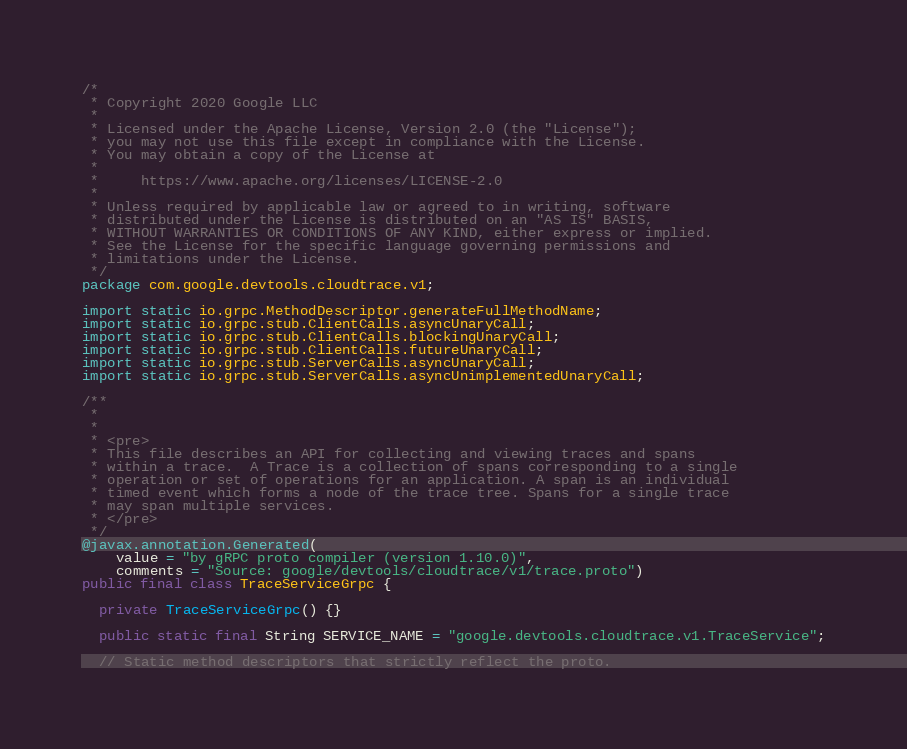Convert code to text. <code><loc_0><loc_0><loc_500><loc_500><_Java_>/*
 * Copyright 2020 Google LLC
 *
 * Licensed under the Apache License, Version 2.0 (the "License");
 * you may not use this file except in compliance with the License.
 * You may obtain a copy of the License at
 *
 *     https://www.apache.org/licenses/LICENSE-2.0
 *
 * Unless required by applicable law or agreed to in writing, software
 * distributed under the License is distributed on an "AS IS" BASIS,
 * WITHOUT WARRANTIES OR CONDITIONS OF ANY KIND, either express or implied.
 * See the License for the specific language governing permissions and
 * limitations under the License.
 */
package com.google.devtools.cloudtrace.v1;

import static io.grpc.MethodDescriptor.generateFullMethodName;
import static io.grpc.stub.ClientCalls.asyncUnaryCall;
import static io.grpc.stub.ClientCalls.blockingUnaryCall;
import static io.grpc.stub.ClientCalls.futureUnaryCall;
import static io.grpc.stub.ServerCalls.asyncUnaryCall;
import static io.grpc.stub.ServerCalls.asyncUnimplementedUnaryCall;

/**
 *
 *
 * <pre>
 * This file describes an API for collecting and viewing traces and spans
 * within a trace.  A Trace is a collection of spans corresponding to a single
 * operation or set of operations for an application. A span is an individual
 * timed event which forms a node of the trace tree. Spans for a single trace
 * may span multiple services.
 * </pre>
 */
@javax.annotation.Generated(
    value = "by gRPC proto compiler (version 1.10.0)",
    comments = "Source: google/devtools/cloudtrace/v1/trace.proto")
public final class TraceServiceGrpc {

  private TraceServiceGrpc() {}

  public static final String SERVICE_NAME = "google.devtools.cloudtrace.v1.TraceService";

  // Static method descriptors that strictly reflect the proto.</code> 